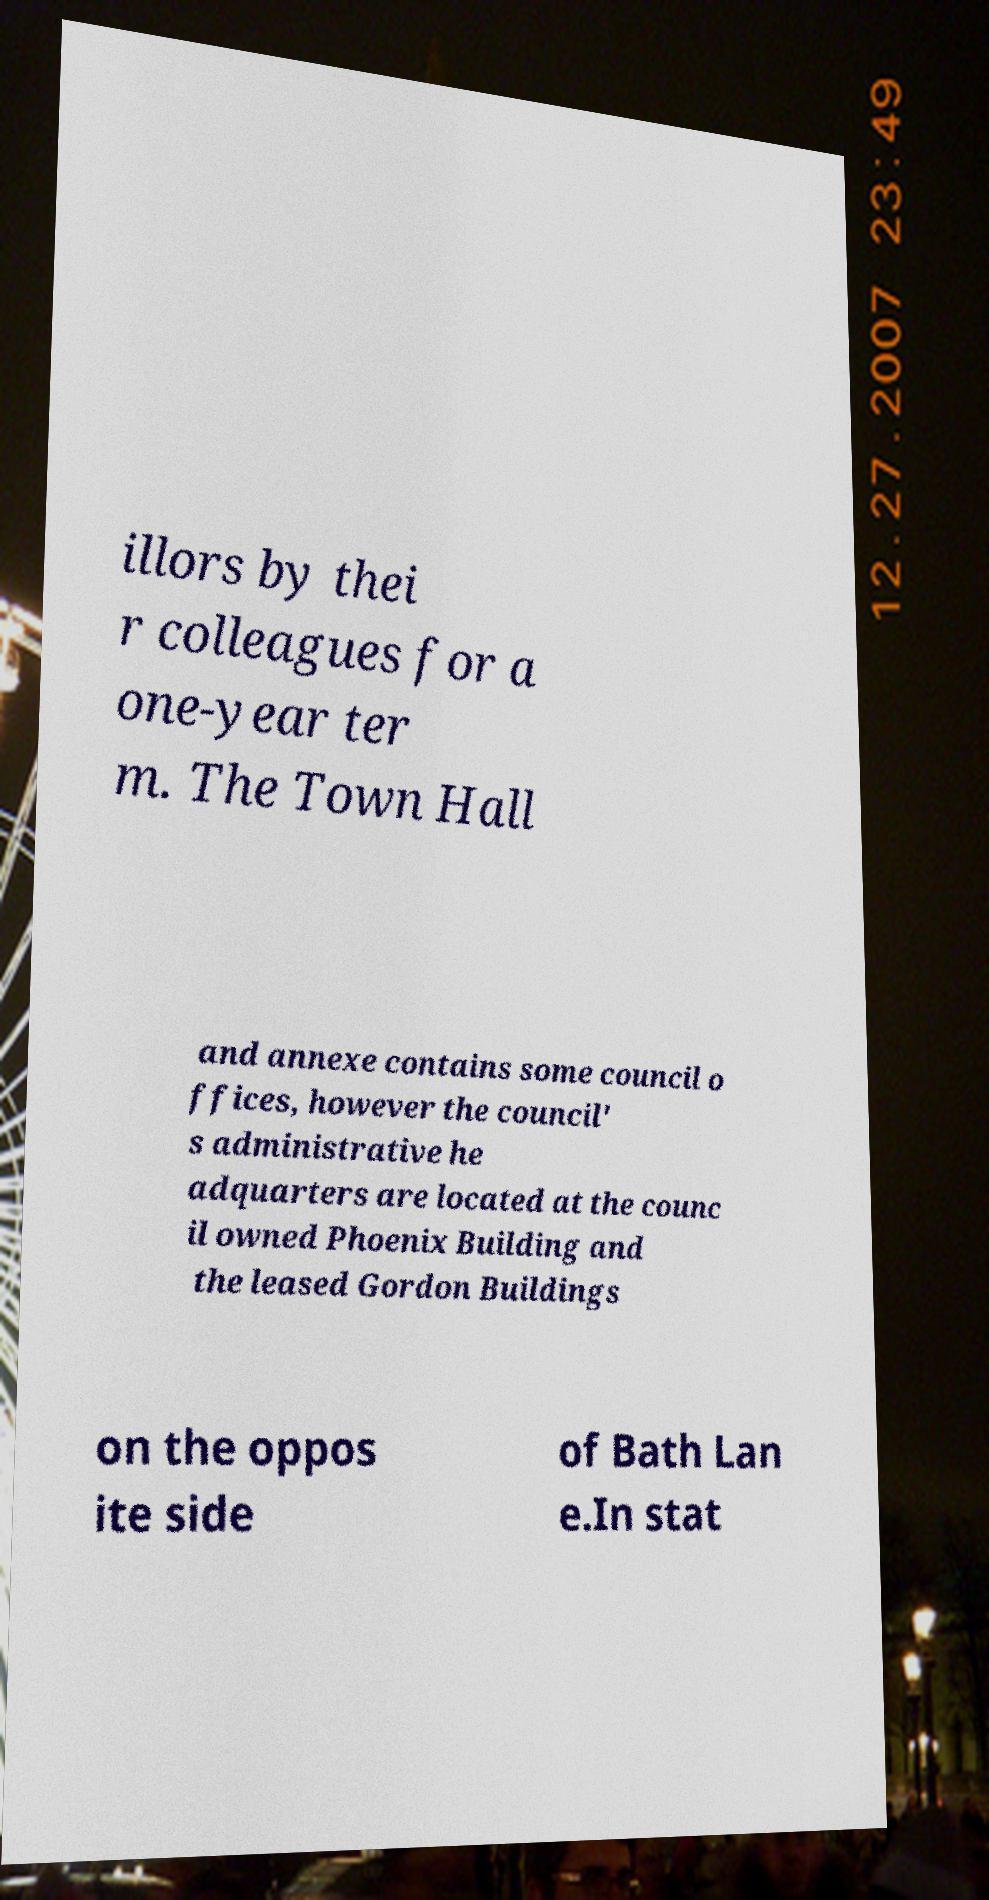Could you assist in decoding the text presented in this image and type it out clearly? illors by thei r colleagues for a one-year ter m. The Town Hall and annexe contains some council o ffices, however the council' s administrative he adquarters are located at the counc il owned Phoenix Building and the leased Gordon Buildings on the oppos ite side of Bath Lan e.In stat 